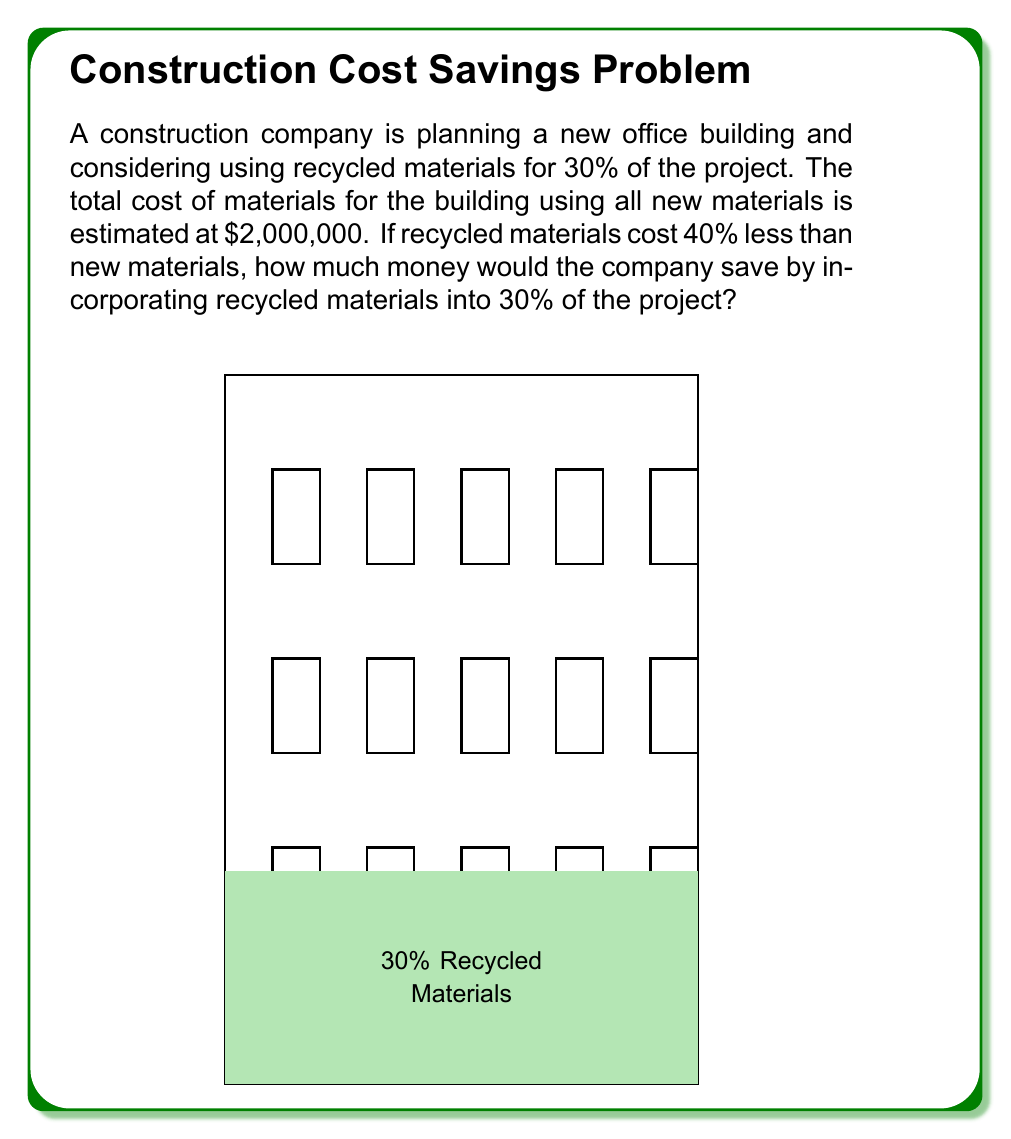Help me with this question. Let's break this problem down step-by-step:

1) First, we need to calculate the cost of the portion of the project that will use recycled materials:
   $30\%$ of $\$2,000,000 = 0.30 \times \$2,000,000 = \$600,000$

2) Now, we know that recycled materials cost 40% less than new materials. This means they cost 60% of the price of new materials. We can calculate the cost of the recycled materials:
   $60\%$ of $\$600,000 = 0.60 \times \$600,000 = \$360,000$

3) To find the savings, we subtract the cost of recycled materials from the original cost for this portion:
   $\$600,000 - \$360,000 = \$240,000$

Therefore, by using recycled materials for 30% of the project, the company would save $240,000.
Answer: $240,000 